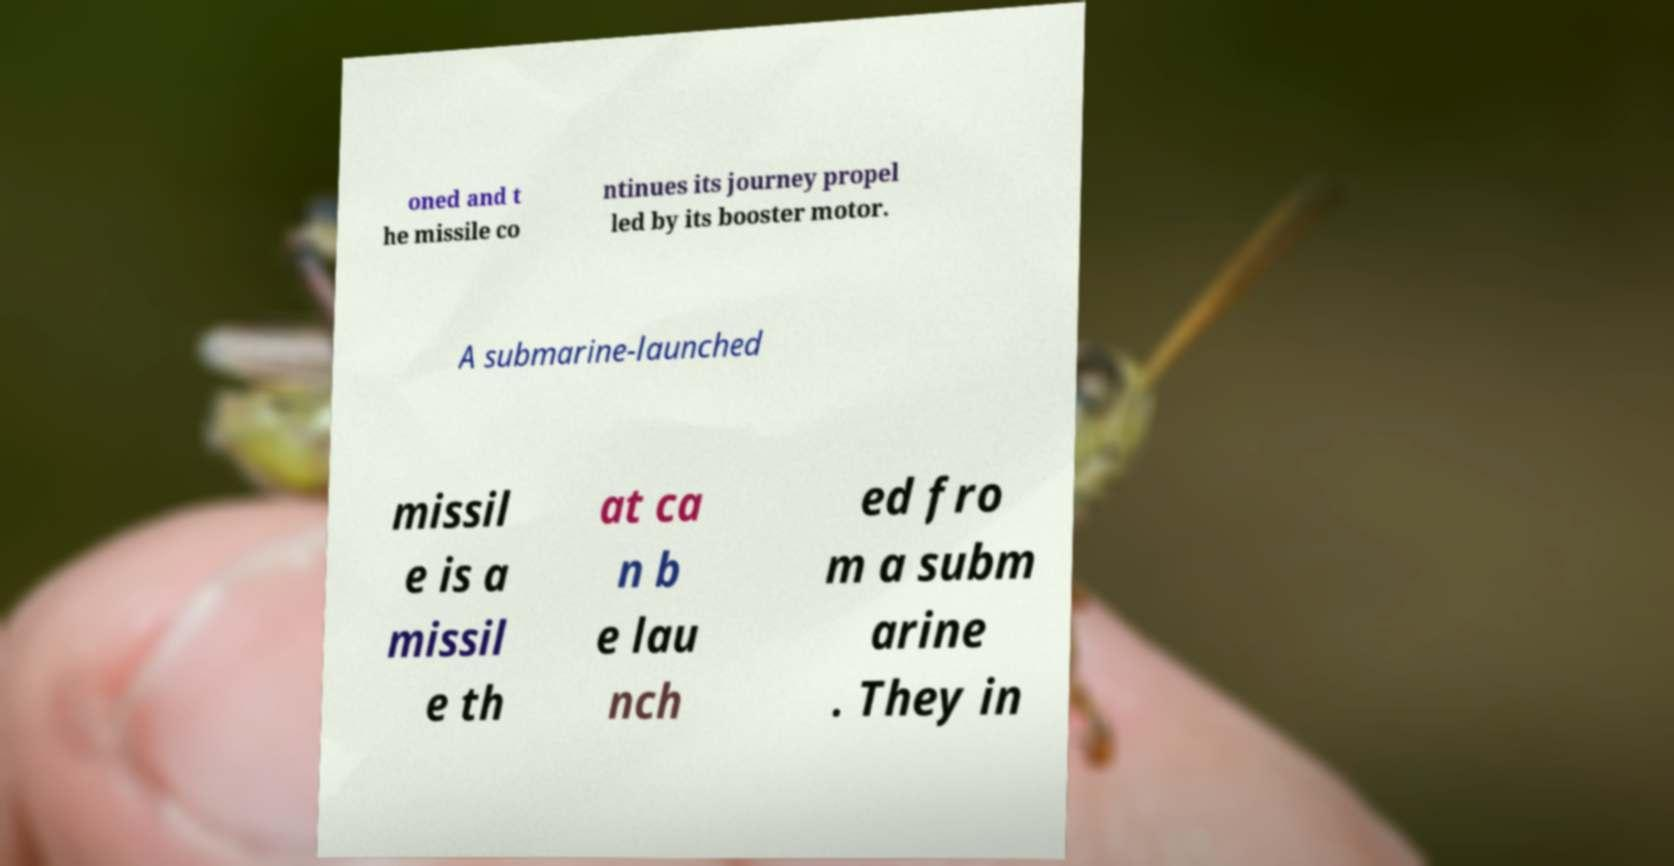Can you accurately transcribe the text from the provided image for me? oned and t he missile co ntinues its journey propel led by its booster motor. A submarine-launched missil e is a missil e th at ca n b e lau nch ed fro m a subm arine . They in 